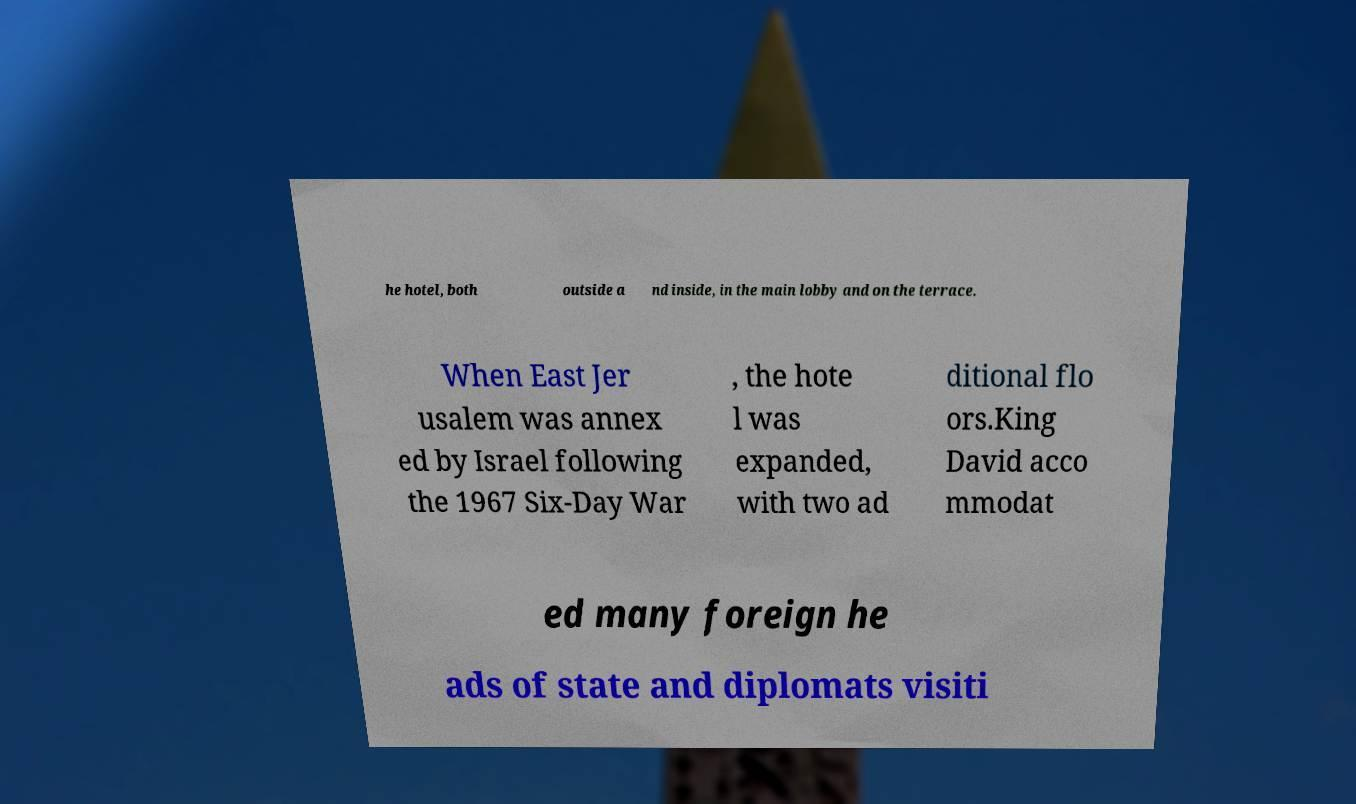Can you accurately transcribe the text from the provided image for me? he hotel, both outside a nd inside, in the main lobby and on the terrace. When East Jer usalem was annex ed by Israel following the 1967 Six-Day War , the hote l was expanded, with two ad ditional flo ors.King David acco mmodat ed many foreign he ads of state and diplomats visiti 